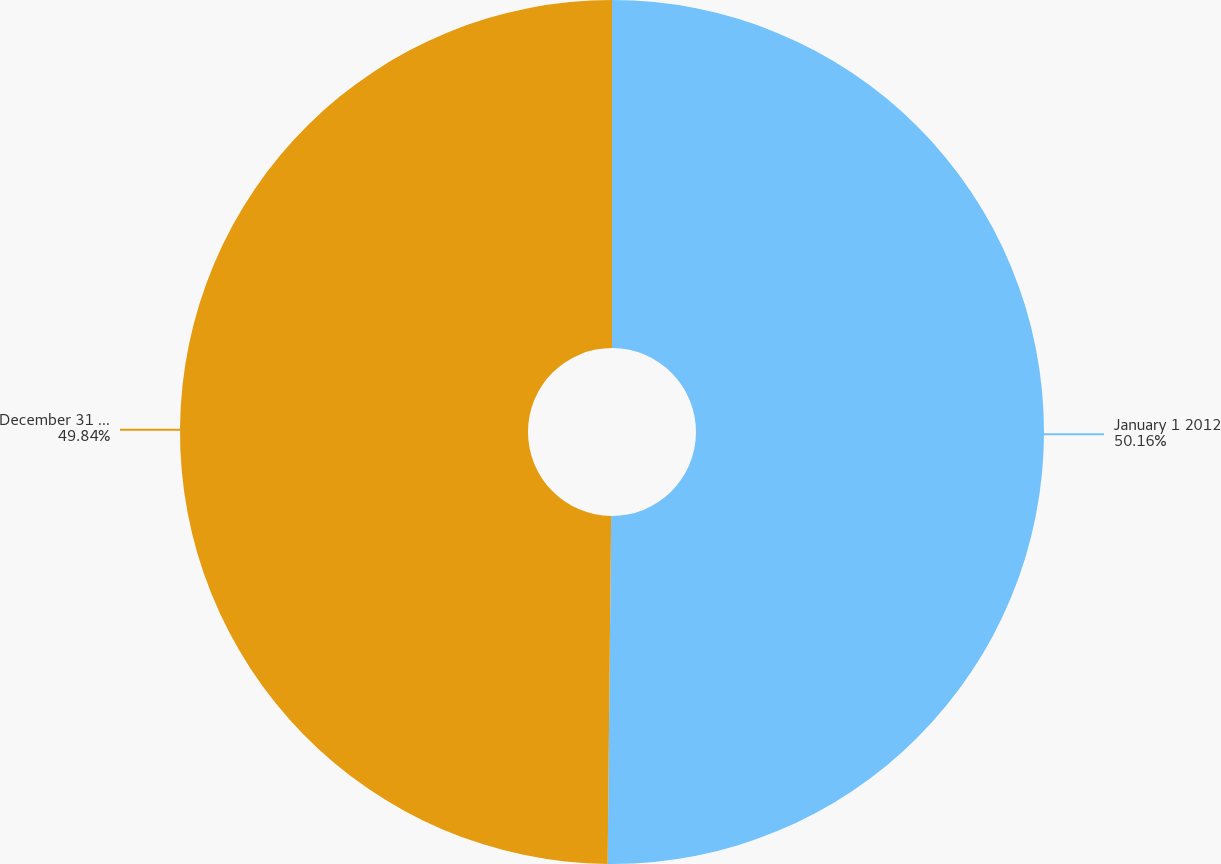Convert chart to OTSL. <chart><loc_0><loc_0><loc_500><loc_500><pie_chart><fcel>January 1 2012<fcel>December 31 2012<nl><fcel>50.16%<fcel>49.84%<nl></chart> 